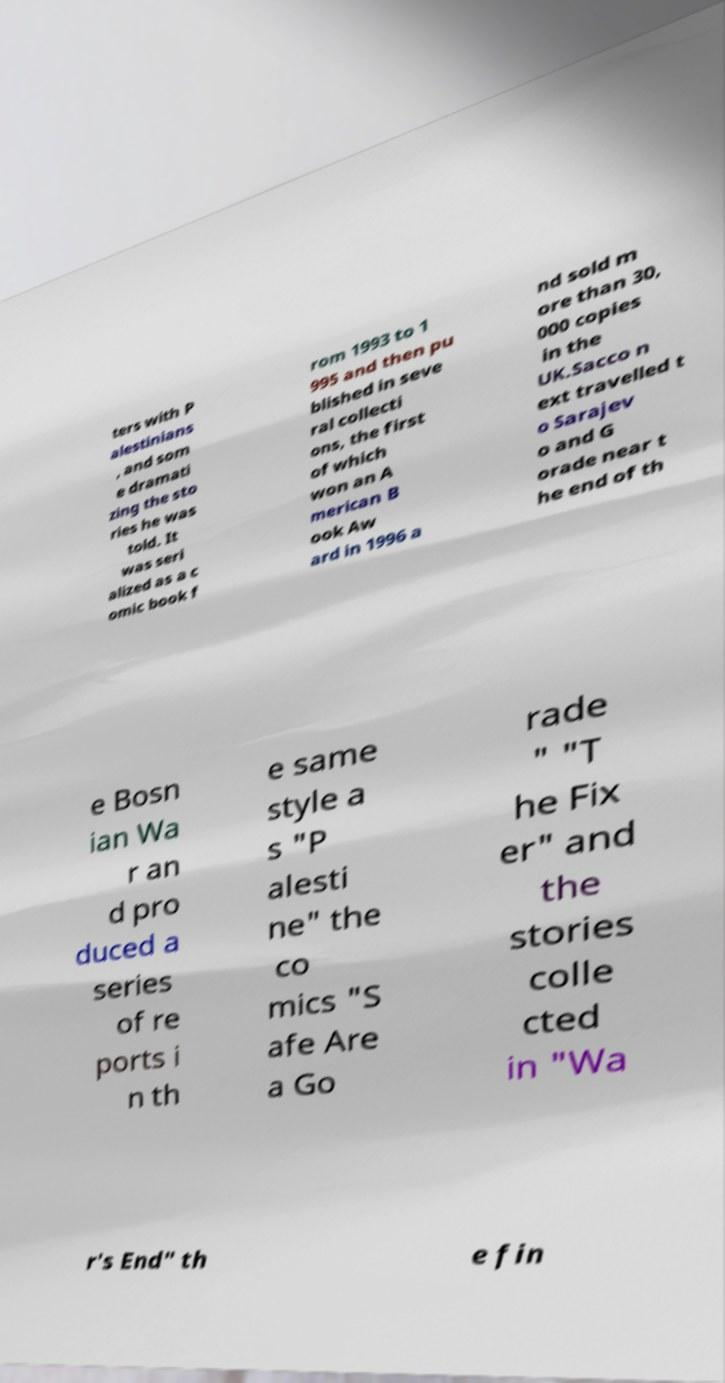Can you read and provide the text displayed in the image?This photo seems to have some interesting text. Can you extract and type it out for me? ters with P alestinians , and som e dramati zing the sto ries he was told. It was seri alized as a c omic book f rom 1993 to 1 995 and then pu blished in seve ral collecti ons, the first of which won an A merican B ook Aw ard in 1996 a nd sold m ore than 30, 000 copies in the UK.Sacco n ext travelled t o Sarajev o and G orade near t he end of th e Bosn ian Wa r an d pro duced a series of re ports i n th e same style a s "P alesti ne" the co mics "S afe Are a Go rade " "T he Fix er" and the stories colle cted in "Wa r's End" th e fin 